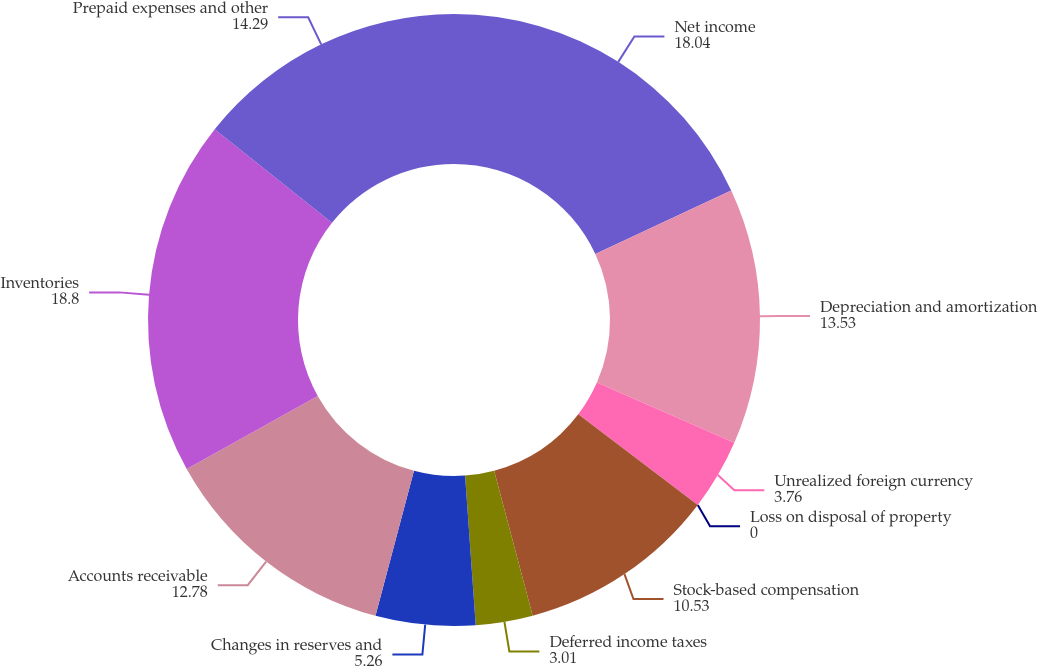<chart> <loc_0><loc_0><loc_500><loc_500><pie_chart><fcel>Net income<fcel>Depreciation and amortization<fcel>Unrealized foreign currency<fcel>Loss on disposal of property<fcel>Stock-based compensation<fcel>Deferred income taxes<fcel>Changes in reserves and<fcel>Accounts receivable<fcel>Inventories<fcel>Prepaid expenses and other<nl><fcel>18.04%<fcel>13.53%<fcel>3.76%<fcel>0.0%<fcel>10.53%<fcel>3.01%<fcel>5.26%<fcel>12.78%<fcel>18.8%<fcel>14.29%<nl></chart> 